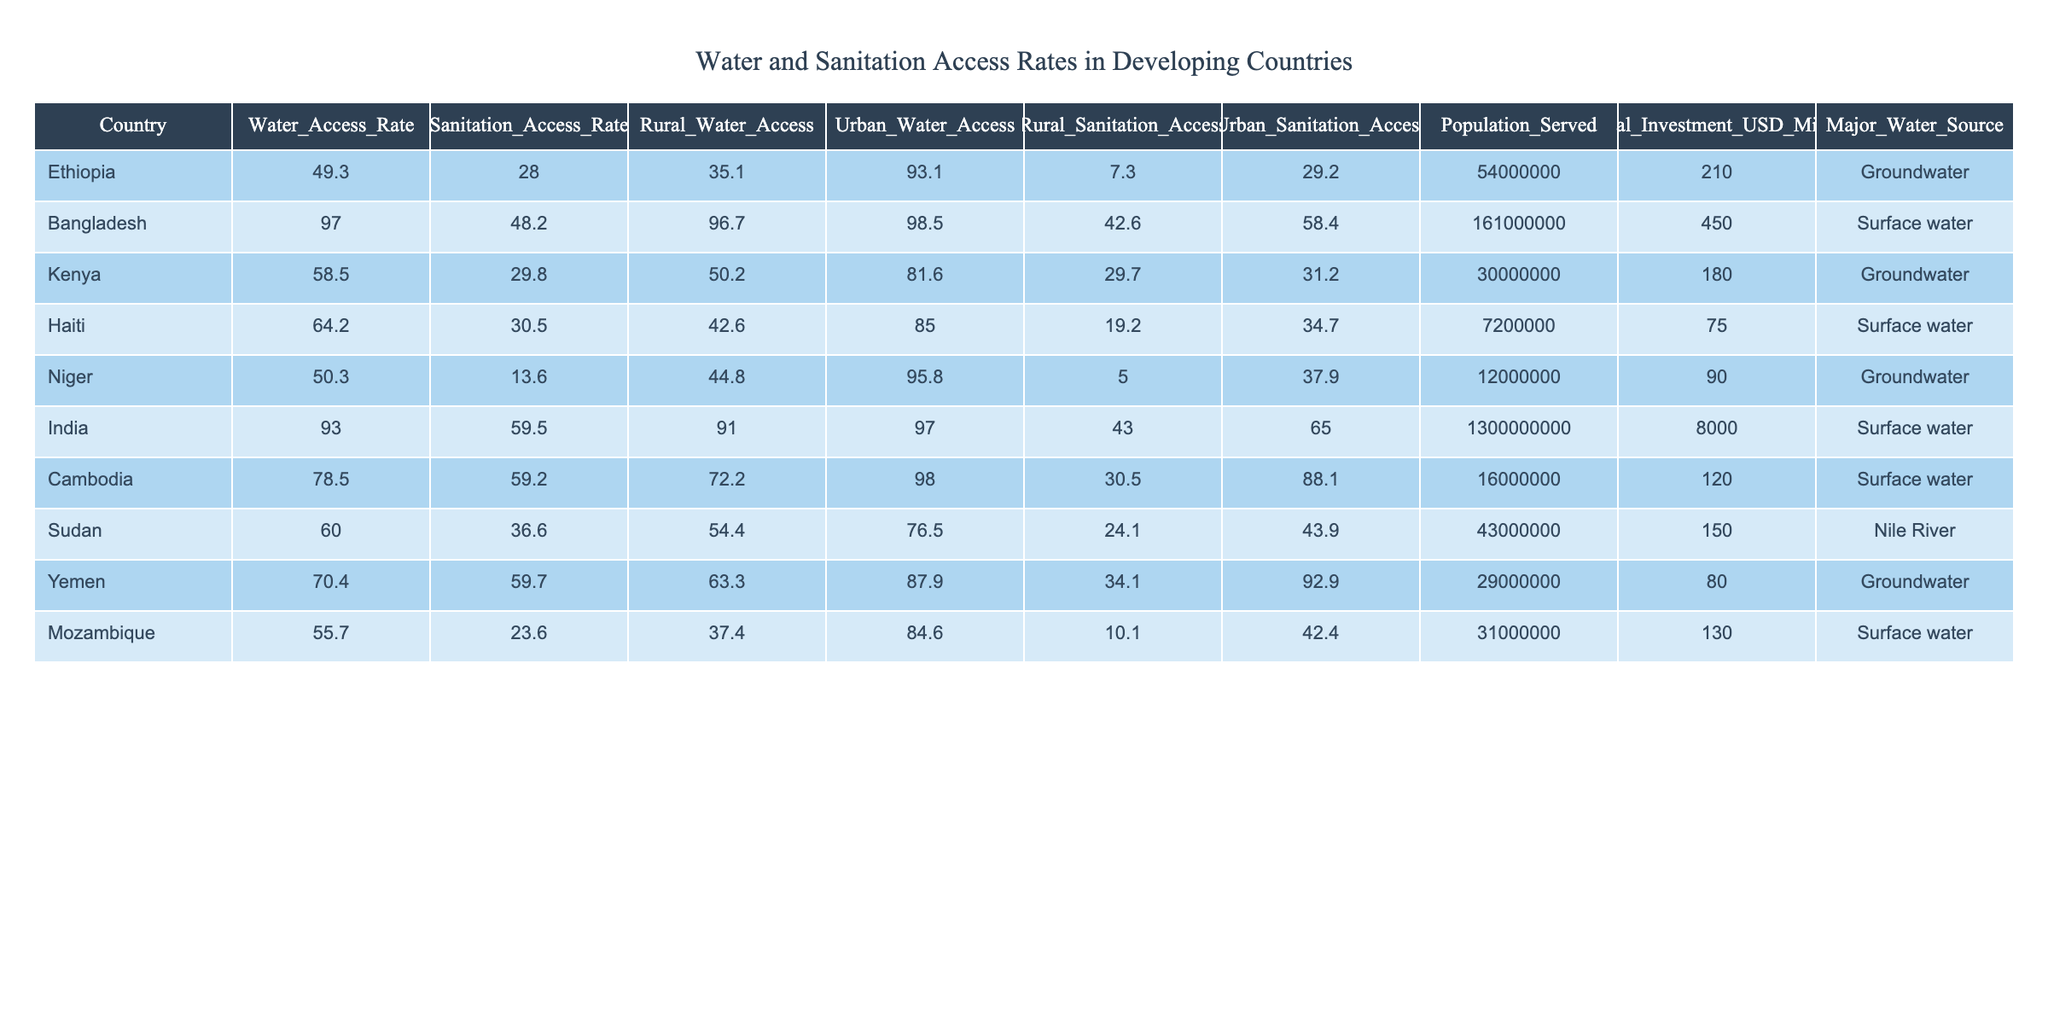What is the Water Access Rate in Bangladesh? The Water Access Rate for Bangladesh is listed directly in the table under the "Water_Access_Rate" column, which shows a value of 97.0.
Answer: 97.0 What is the Sanitation Access Rate for India? Referring to the table, the Sanitation Access Rate for India can be found in the "Sanitation_Access_Rate" column, and it is noted as 59.5.
Answer: 59.5 Which country has the lowest Sanitation Access Rate? Looking through the "Sanitation_Access_Rate" column in the table, Niger has the lowest value at 13.6.
Answer: Niger What is the difference in Urban Water Access between Ethiopia and Kenya? The Urban Water Access for Ethiopia is 93.1 and for Kenya is 81.6. Calculating the difference: 93.1 - 81.6 = 11.5.
Answer: 11.5 What is the average Rural Water Access Rate across the countries listed? Summing the Rural Water Access Rates: (35.1 + 96.7 + 50.2 + 42.6 + 44.8 + 91.0 + 72.2 + 54.4 + 63.3 + 37.4) = 535.7. There are 10 countries, so the average is 535.7 / 10 = 53.57.
Answer: 53.57 Is the Major Water Source in Haiti Surface Water? According to the "Major_Water_Source" column for Haiti, the entry is "Surface water." Hence, the statement is true.
Answer: True Which country has the highest population served, and what is that number? By analyzing the "Population_Served" column, India has the highest population served with a value of 1,300,000,000.
Answer: 1,300,000,000 What is the total Annual Investment for water and sanitation for the listed countries? Adding the Annual Investment values: 210 + 450 + 180 + 75 + 90 + 8000 + 120 + 150 + 80 + 130 = 9,705 million USD.
Answer: 9,705 million USD Which country has a Rural Water Access Rate higher than 75% and what is that rate? The only country exceeding a Rural Water Access Rate of 75% is Bangladesh at a rate of 96.7%.
Answer: 96.7% Is it true that Mozambique has a higher Urban Sanitation Access Rate than Ethiopia? Referring to the table, Mozambique has an Urban Sanitation Access Rate of 42.4 while Ethiopia's rate is 29.2. Thus, it is indeed true.
Answer: True 